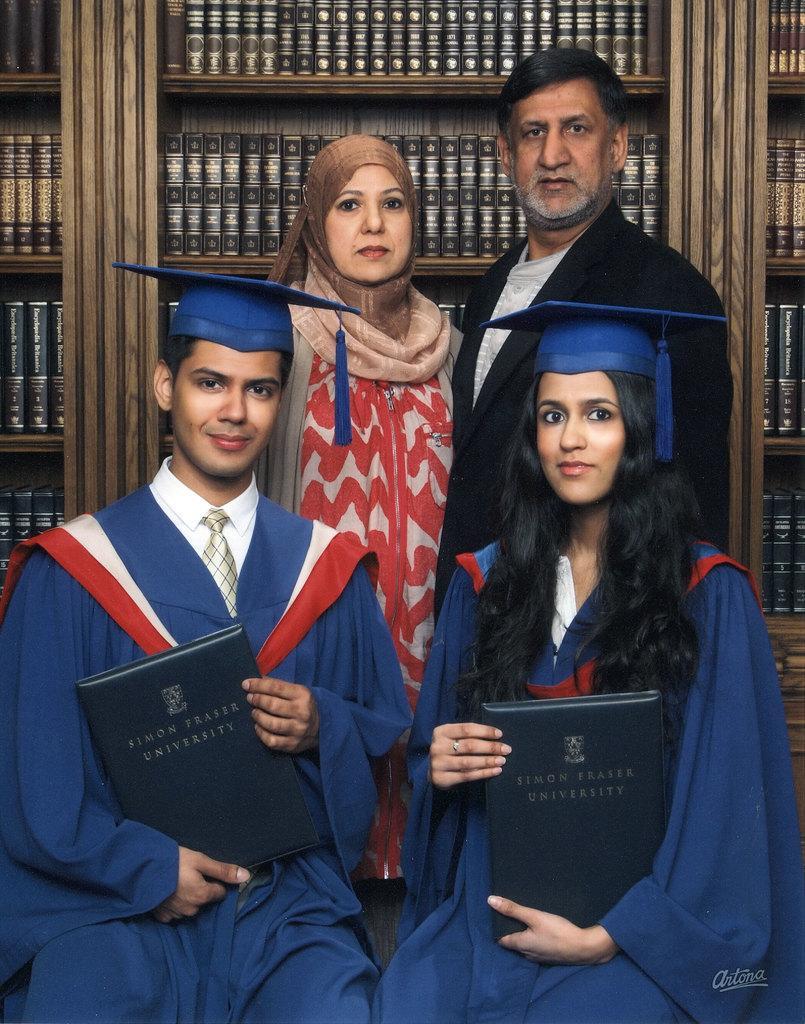Please provide a concise description of this image. Here we can see four people. These two people are sitting and holding books. Backside of these people there are cracks filled with books.  